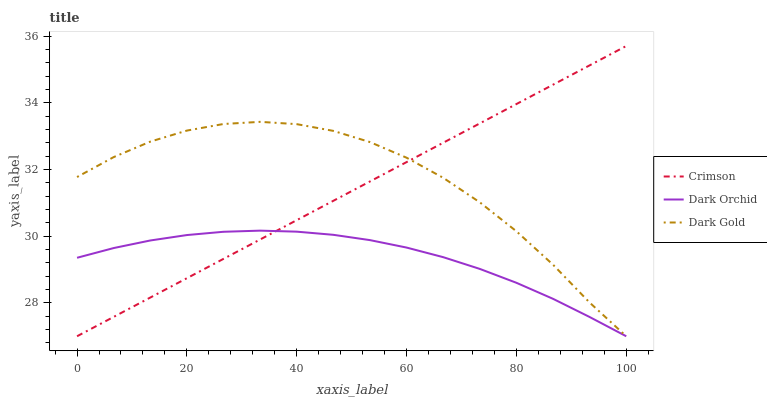Does Dark Orchid have the minimum area under the curve?
Answer yes or no. Yes. Does Dark Gold have the maximum area under the curve?
Answer yes or no. Yes. Does Dark Gold have the minimum area under the curve?
Answer yes or no. No. Does Dark Orchid have the maximum area under the curve?
Answer yes or no. No. Is Crimson the smoothest?
Answer yes or no. Yes. Is Dark Gold the roughest?
Answer yes or no. Yes. Is Dark Orchid the smoothest?
Answer yes or no. No. Is Dark Orchid the roughest?
Answer yes or no. No. Does Crimson have the lowest value?
Answer yes or no. Yes. Does Crimson have the highest value?
Answer yes or no. Yes. Does Dark Gold have the highest value?
Answer yes or no. No. Does Dark Orchid intersect Dark Gold?
Answer yes or no. Yes. Is Dark Orchid less than Dark Gold?
Answer yes or no. No. Is Dark Orchid greater than Dark Gold?
Answer yes or no. No. 